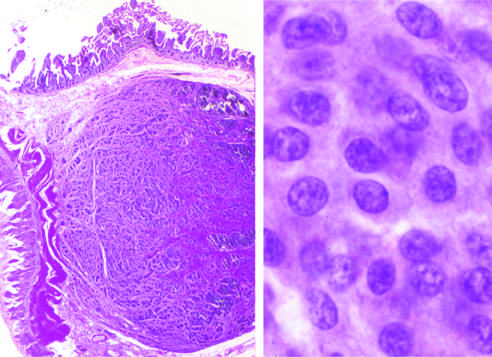what assumes a salt-and-pepper pattern?
Answer the question using a single word or phrase. The chromatin texture 